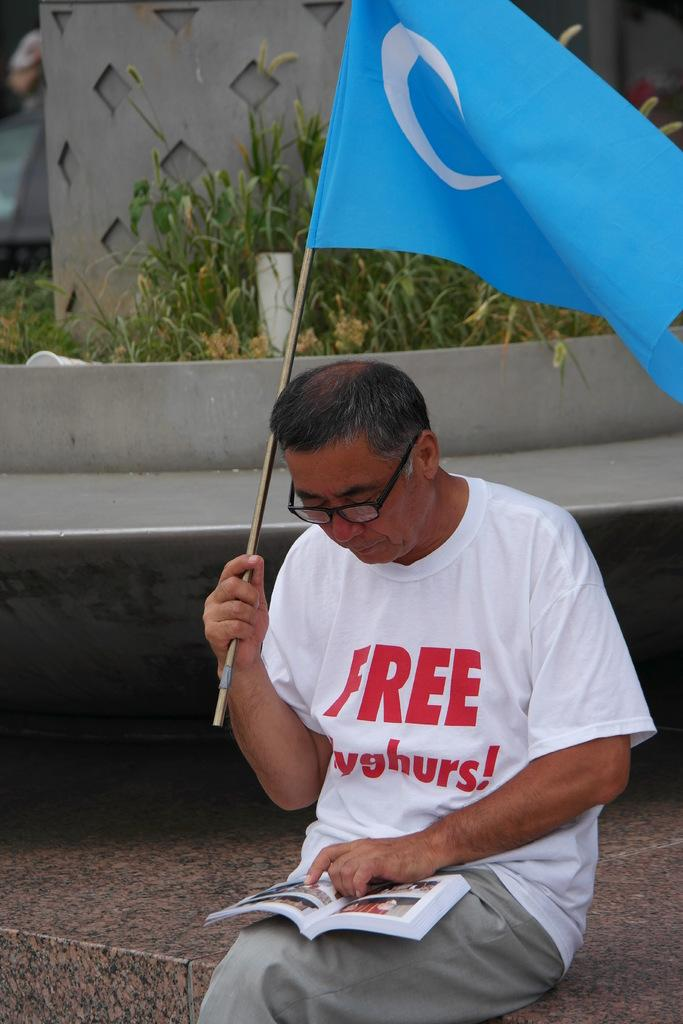What is the person in the image doing? The person is sitting in the image. What is the person holding in the image? The person is holding a flag and a book on their lap. What can be seen on the person's face? The person is wearing glasses. What is visible in the background of the image? There are grasses and a small wall in the background of the image. What type of orange is the person eating in the image? There is no orange present in the image; the person is holding a flag and a book on their lap. 